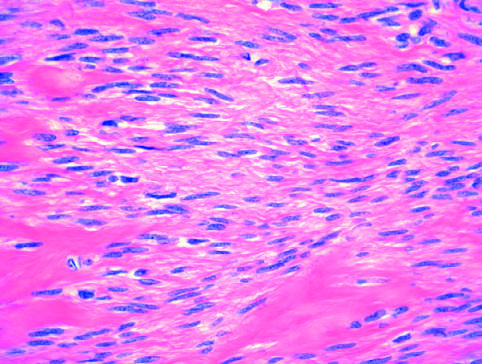does microscopic appearance of leiomyoma show bundles of normal-looking smooth muscle cells?
Answer the question using a single word or phrase. Yes 